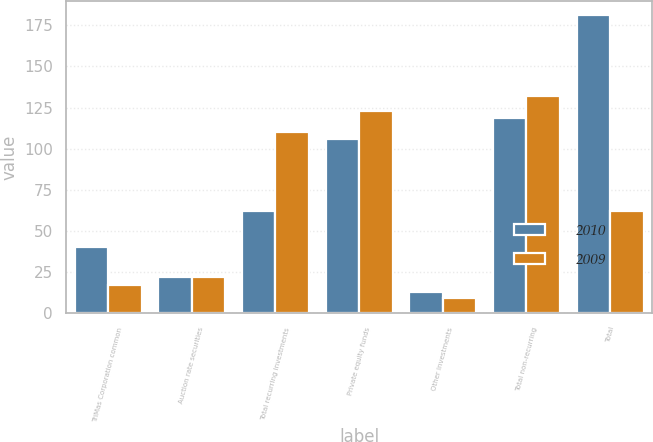Convert chart to OTSL. <chart><loc_0><loc_0><loc_500><loc_500><stacked_bar_chart><ecel><fcel>TriMas Corporation common<fcel>Auction rate securities<fcel>Total recurring investments<fcel>Private equity funds<fcel>Other investments<fcel>Total non-recurring<fcel>Total<nl><fcel>2010<fcel>40<fcel>22<fcel>62<fcel>106<fcel>13<fcel>119<fcel>181<nl><fcel>2009<fcel>17<fcel>22<fcel>110<fcel>123<fcel>9<fcel>132<fcel>62<nl></chart> 